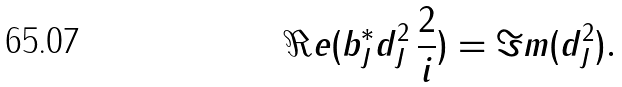Convert formula to latex. <formula><loc_0><loc_0><loc_500><loc_500>\Re e ( b _ { J } ^ { * } d ^ { 2 } _ { J } \, \frac { 2 } { i } ) = \Im m ( d ^ { 2 } _ { J } ) .</formula> 